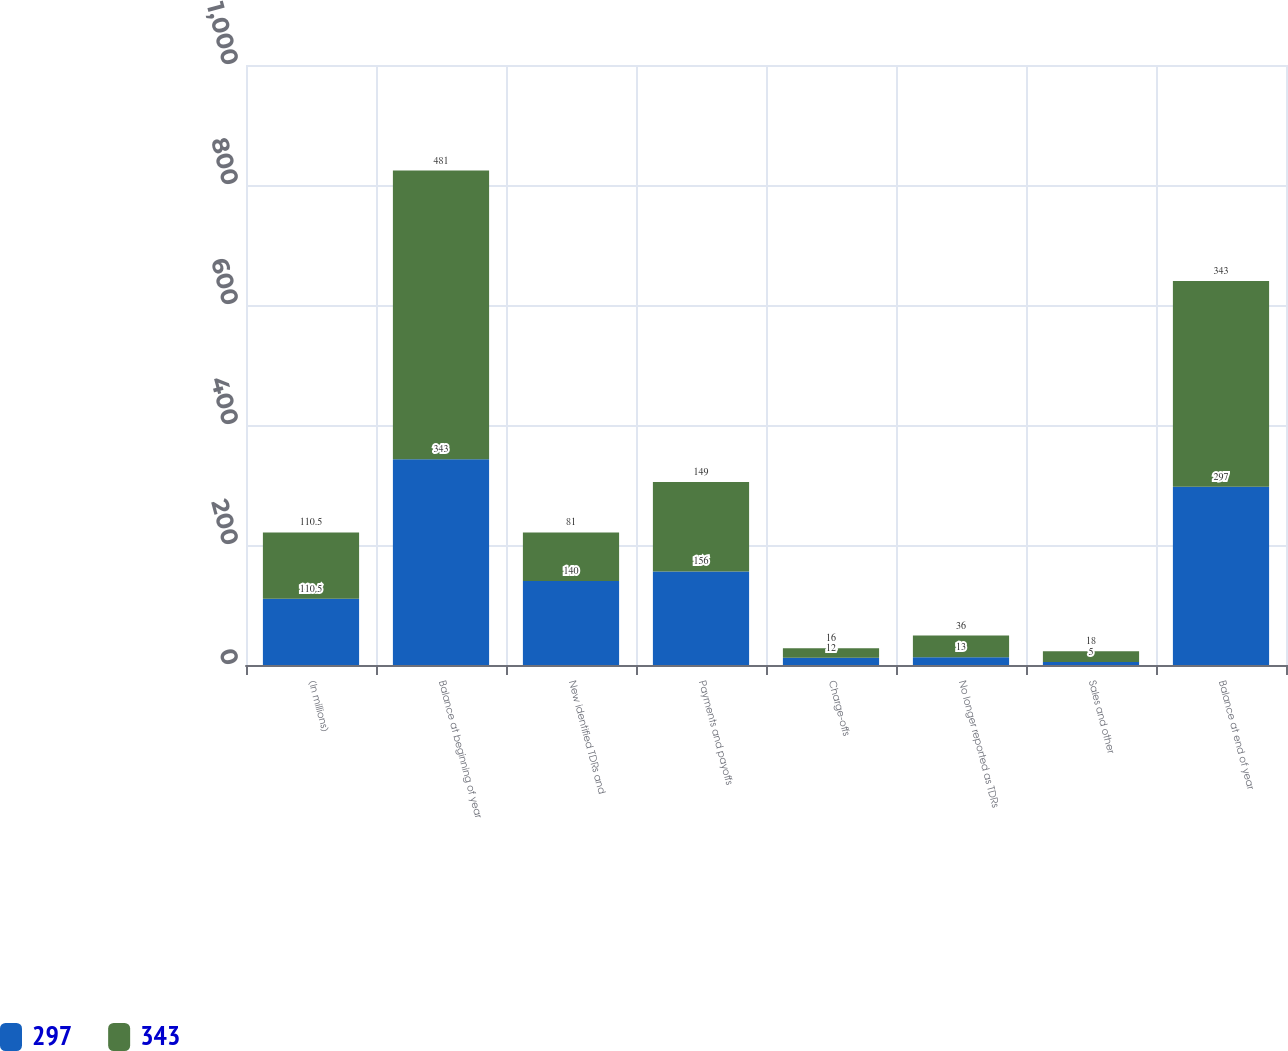Convert chart to OTSL. <chart><loc_0><loc_0><loc_500><loc_500><stacked_bar_chart><ecel><fcel>(In millions)<fcel>Balance at beginning of year<fcel>New identified TDRs and<fcel>Payments and payoffs<fcel>Charge-offs<fcel>No longer reported as TDRs<fcel>Sales and other<fcel>Balance at end of year<nl><fcel>297<fcel>110.5<fcel>343<fcel>140<fcel>156<fcel>12<fcel>13<fcel>5<fcel>297<nl><fcel>343<fcel>110.5<fcel>481<fcel>81<fcel>149<fcel>16<fcel>36<fcel>18<fcel>343<nl></chart> 